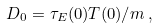Convert formula to latex. <formula><loc_0><loc_0><loc_500><loc_500>D _ { 0 } = \tau _ { E } ( 0 ) T ( 0 ) / m \, ,</formula> 